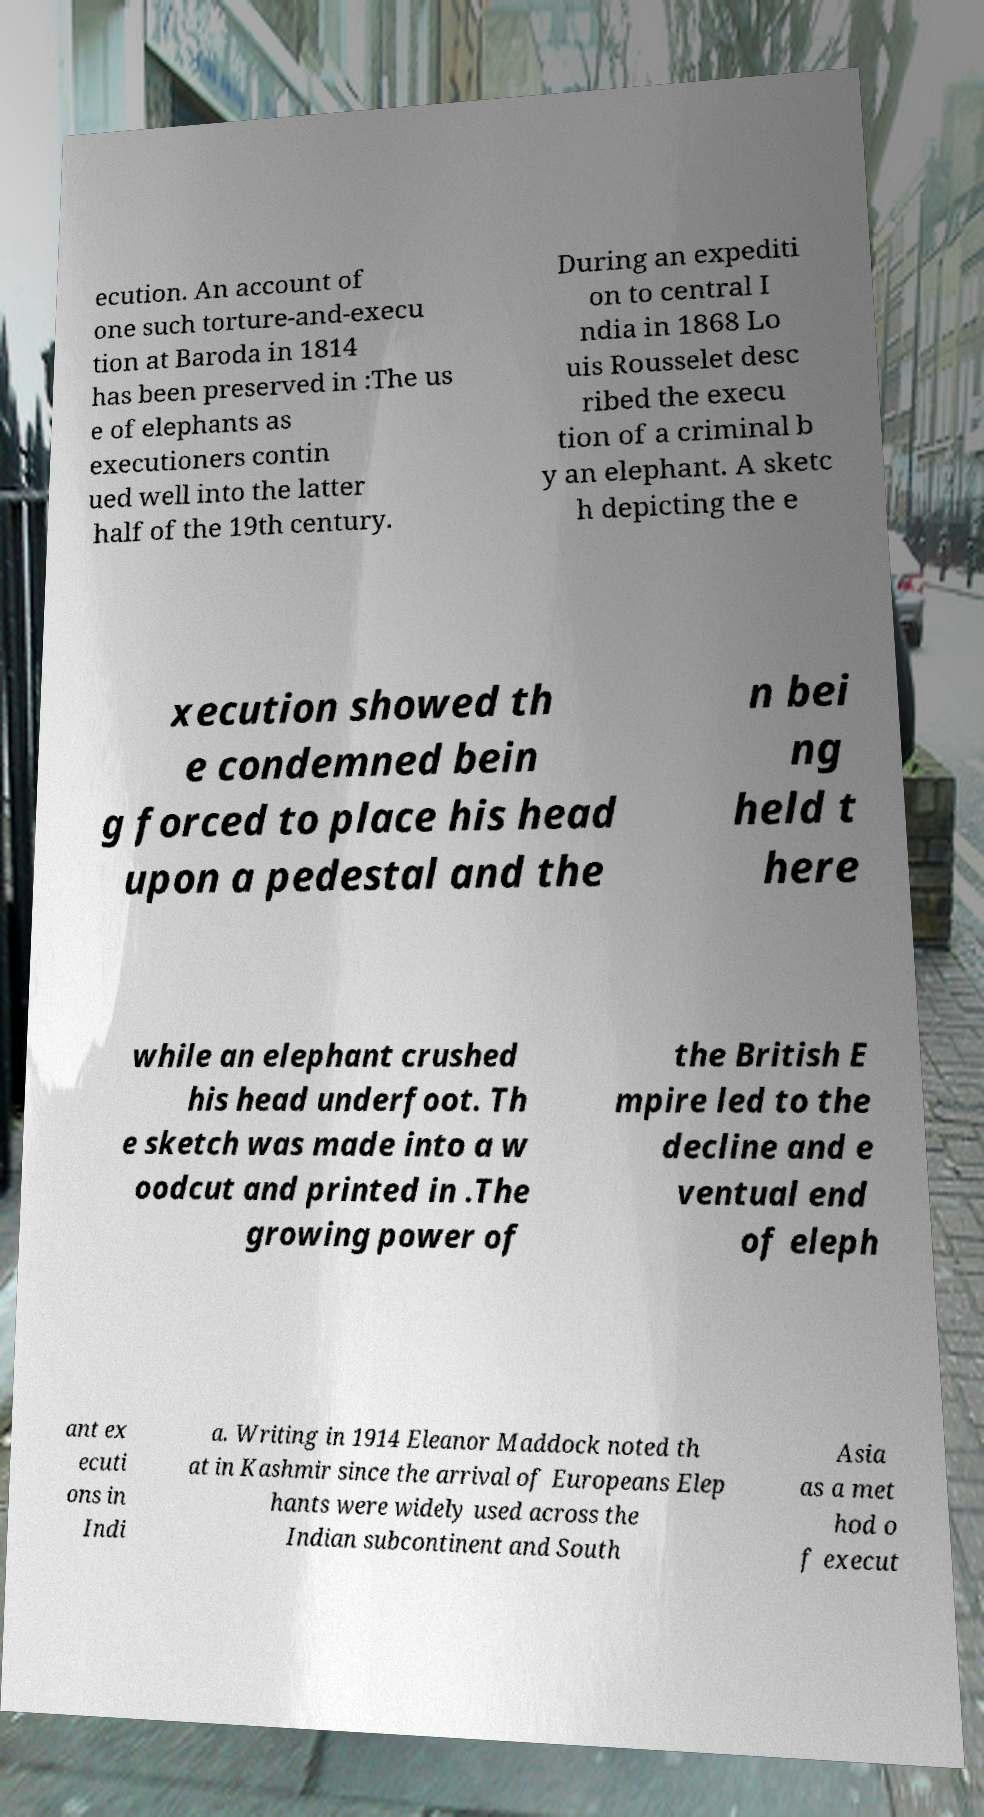For documentation purposes, I need the text within this image transcribed. Could you provide that? ecution. An account of one such torture-and-execu tion at Baroda in 1814 has been preserved in :The us e of elephants as executioners contin ued well into the latter half of the 19th century. During an expediti on to central I ndia in 1868 Lo uis Rousselet desc ribed the execu tion of a criminal b y an elephant. A sketc h depicting the e xecution showed th e condemned bein g forced to place his head upon a pedestal and the n bei ng held t here while an elephant crushed his head underfoot. Th e sketch was made into a w oodcut and printed in .The growing power of the British E mpire led to the decline and e ventual end of eleph ant ex ecuti ons in Indi a. Writing in 1914 Eleanor Maddock noted th at in Kashmir since the arrival of Europeans Elep hants were widely used across the Indian subcontinent and South Asia as a met hod o f execut 